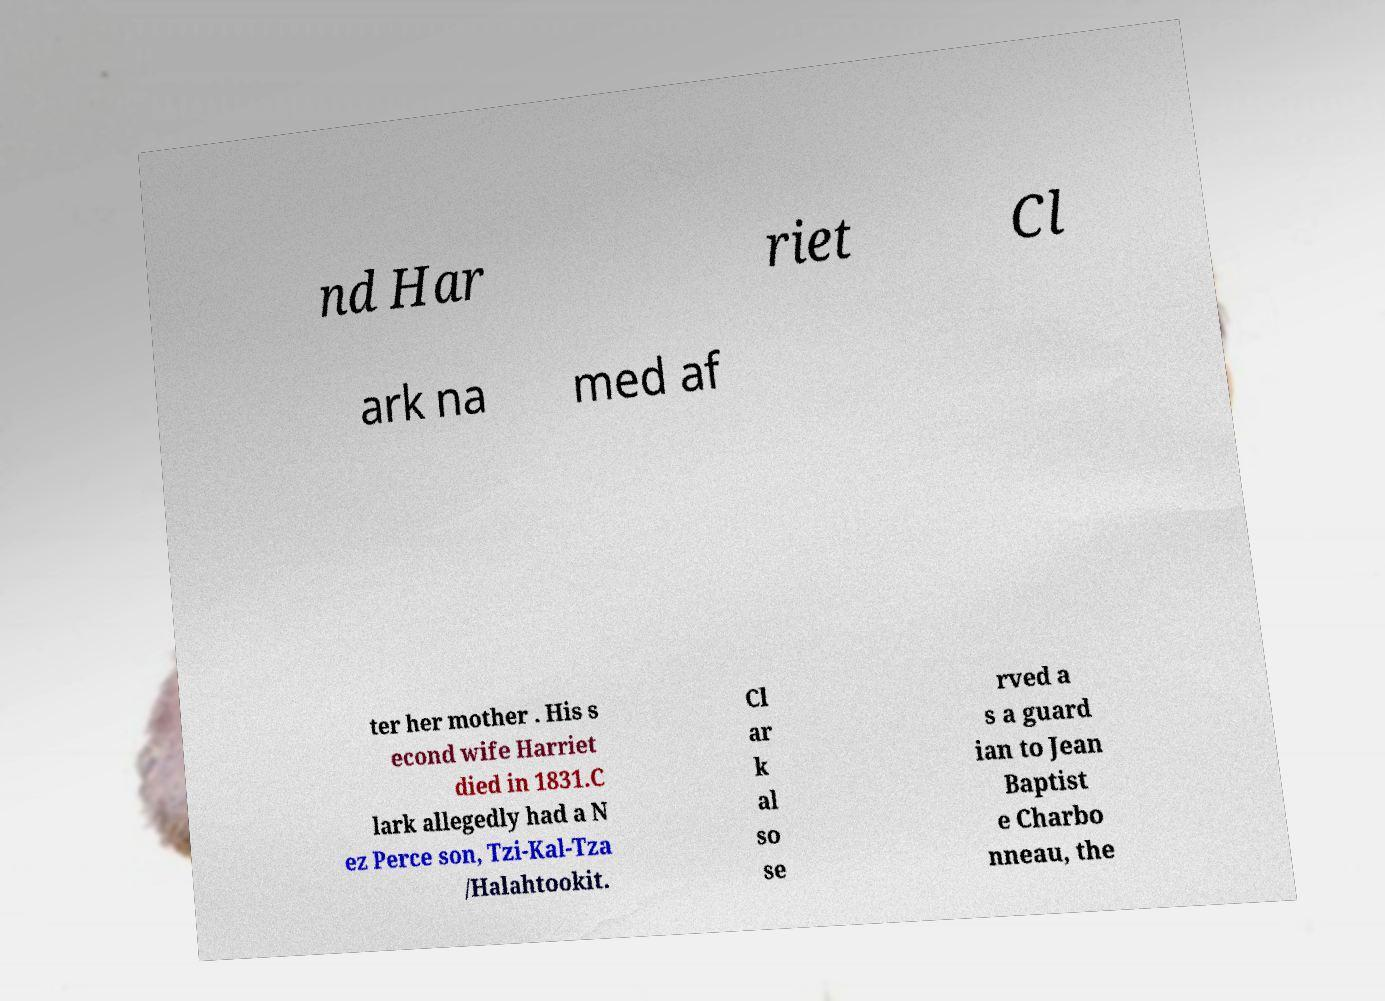There's text embedded in this image that I need extracted. Can you transcribe it verbatim? nd Har riet Cl ark na med af ter her mother . His s econd wife Harriet died in 1831.C lark allegedly had a N ez Perce son, Tzi-Kal-Tza /Halahtookit. Cl ar k al so se rved a s a guard ian to Jean Baptist e Charbo nneau, the 